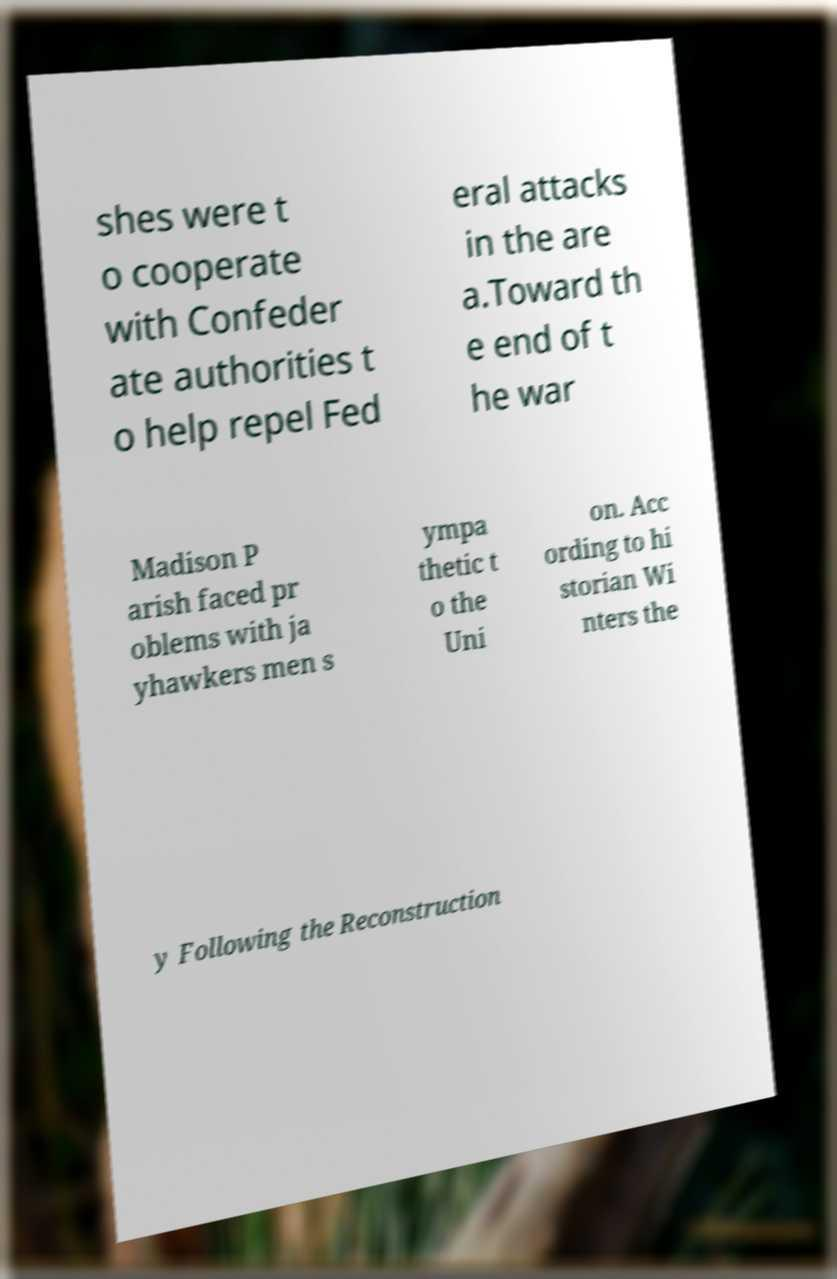Please read and relay the text visible in this image. What does it say? shes were t o cooperate with Confeder ate authorities t o help repel Fed eral attacks in the are a.Toward th e end of t he war Madison P arish faced pr oblems with ja yhawkers men s ympa thetic t o the Uni on. Acc ording to hi storian Wi nters the y Following the Reconstruction 